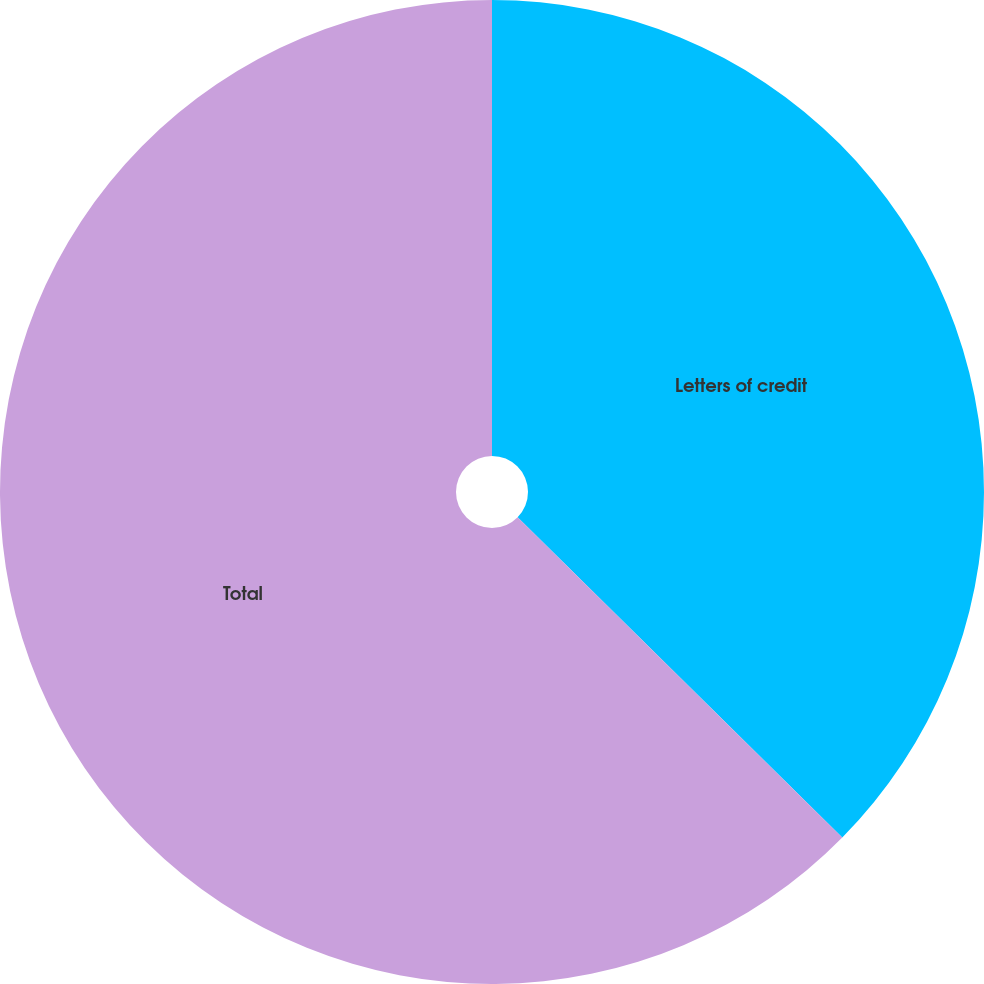<chart> <loc_0><loc_0><loc_500><loc_500><pie_chart><fcel>Letters of credit<fcel>Total<nl><fcel>37.39%<fcel>62.61%<nl></chart> 